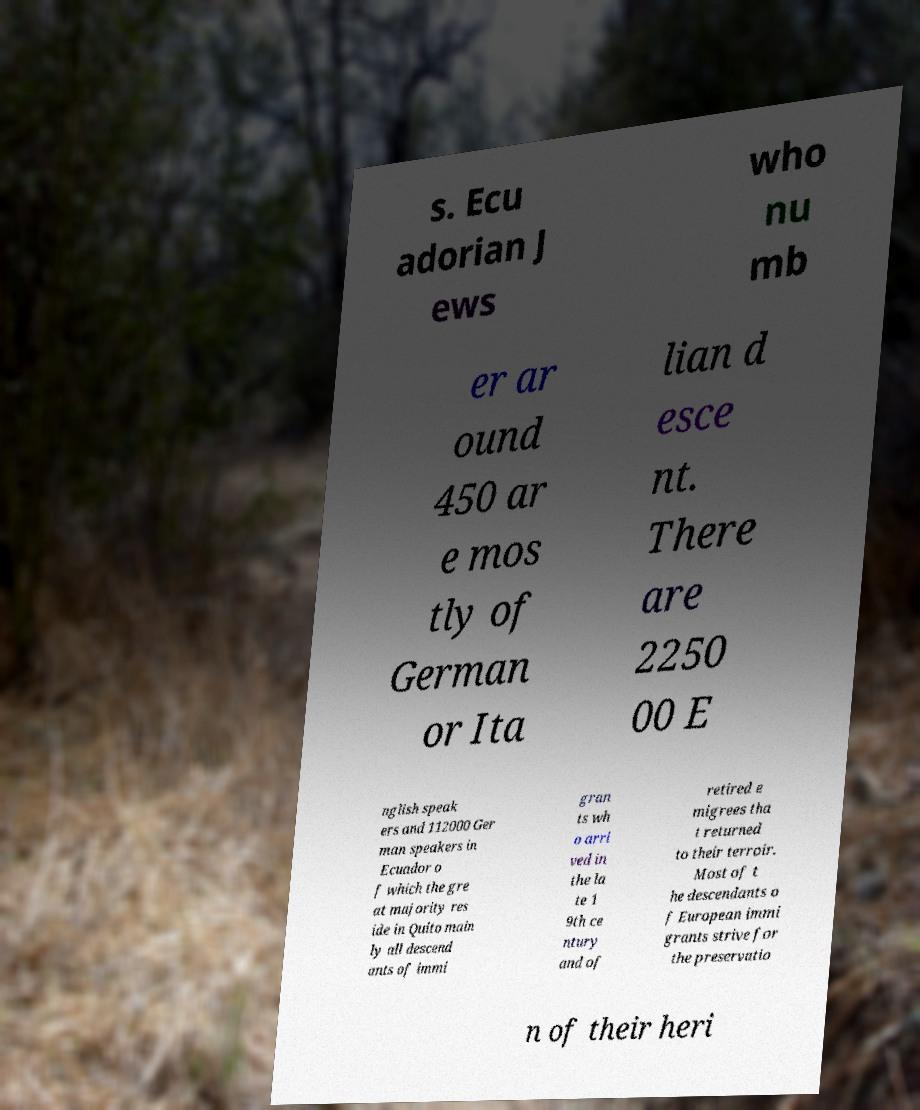I need the written content from this picture converted into text. Can you do that? s. Ecu adorian J ews who nu mb er ar ound 450 ar e mos tly of German or Ita lian d esce nt. There are 2250 00 E nglish speak ers and 112000 Ger man speakers in Ecuador o f which the gre at majority res ide in Quito main ly all descend ants of immi gran ts wh o arri ved in the la te 1 9th ce ntury and of retired e migrees tha t returned to their terroir. Most of t he descendants o f European immi grants strive for the preservatio n of their heri 